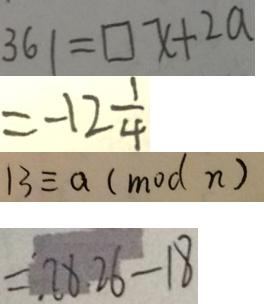Convert formula to latex. <formula><loc_0><loc_0><loc_500><loc_500>3 6 1 = \square x + 2 a 
 = - 1 2 \frac { 1 } { 4 } 
 1 3 \equiv a ( m o d n ) 
 = 2 8 . 2 6 - 1 8</formula> 